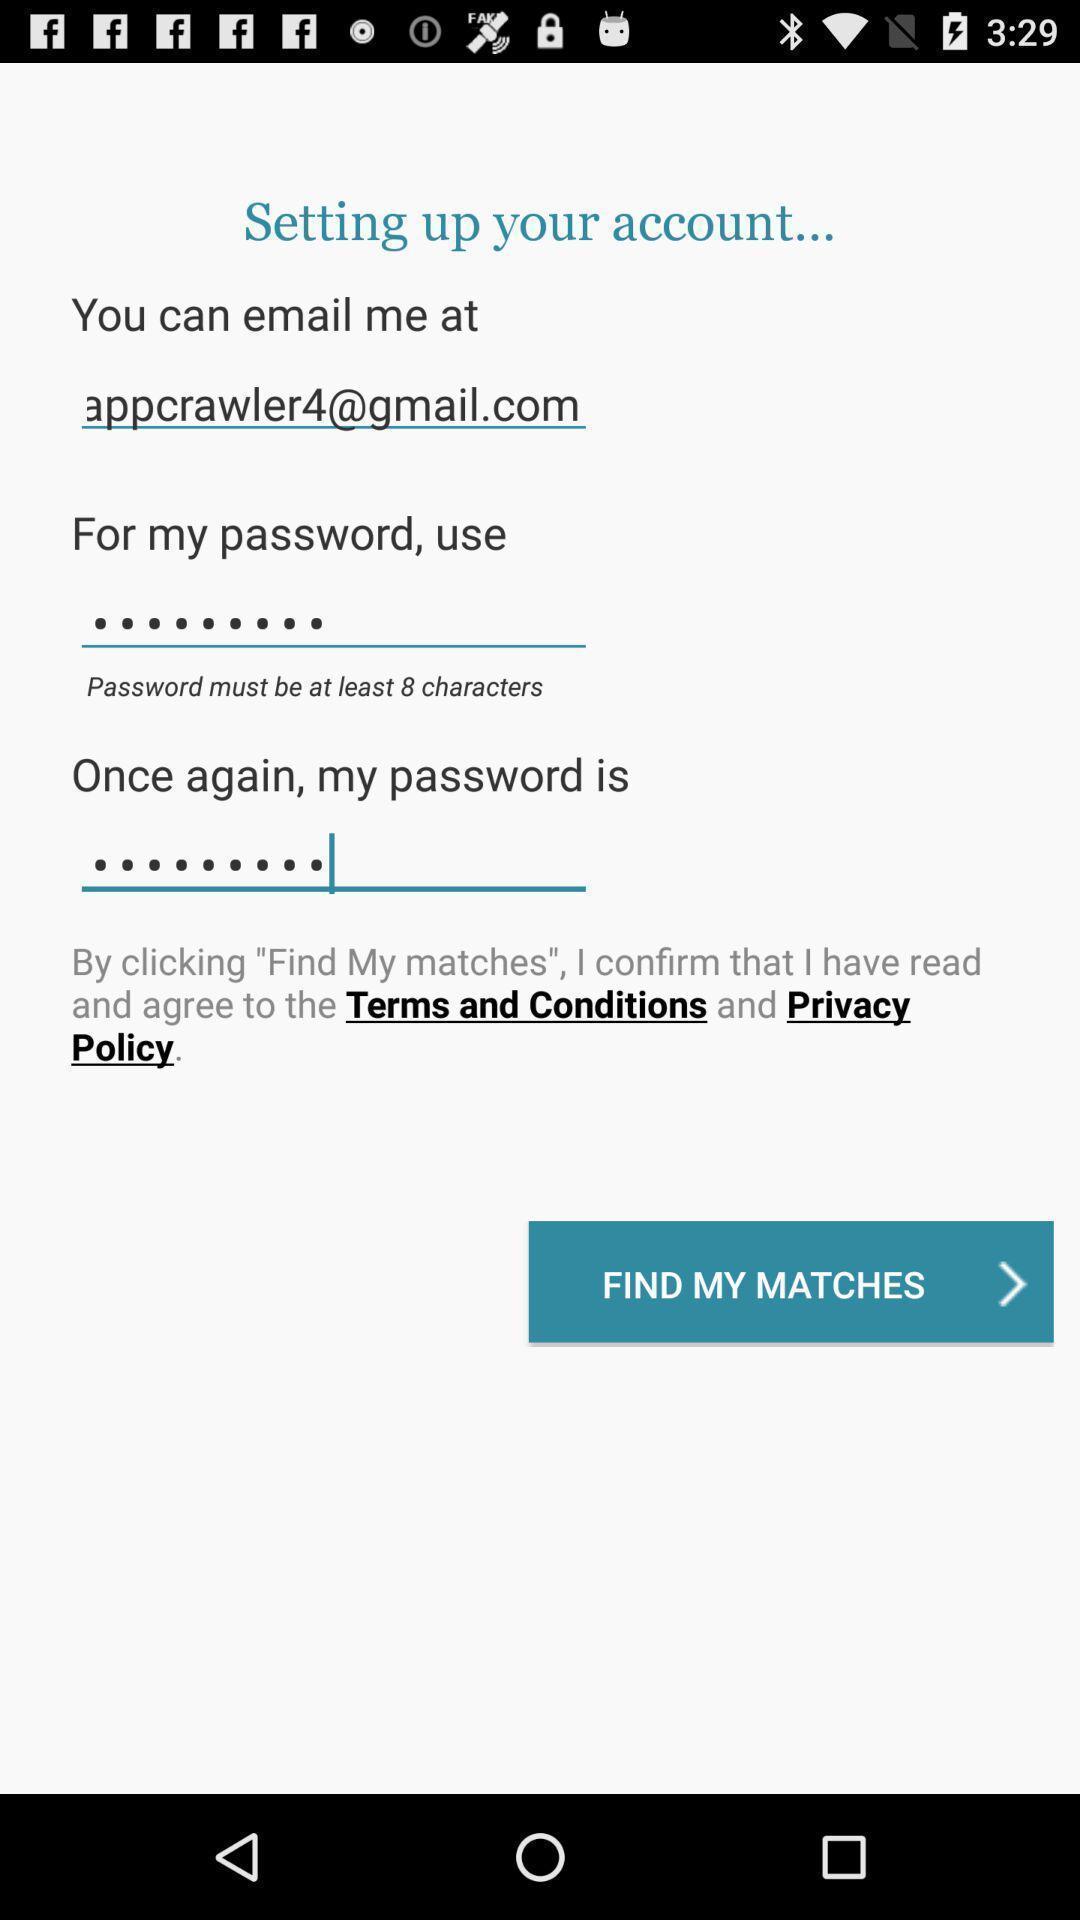Provide a textual representation of this image. Sign-up page of a social app. 